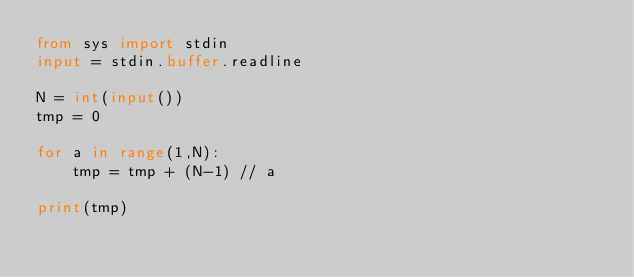<code> <loc_0><loc_0><loc_500><loc_500><_Python_>from sys import stdin
input = stdin.buffer.readline

N = int(input())
tmp = 0

for a in range(1,N):
    tmp = tmp + (N-1) // a
    
print(tmp)</code> 